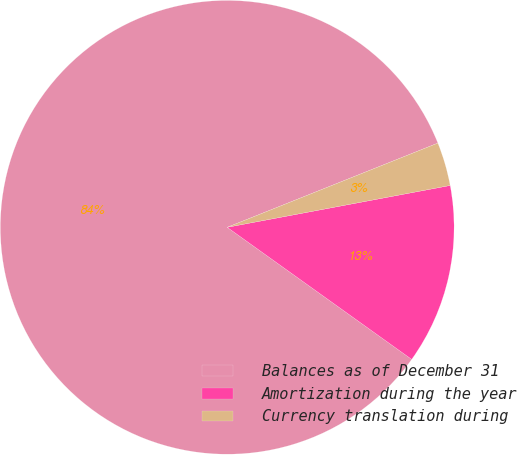Convert chart. <chart><loc_0><loc_0><loc_500><loc_500><pie_chart><fcel>Balances as of December 31<fcel>Amortization during the year<fcel>Currency translation during<nl><fcel>84.06%<fcel>12.84%<fcel>3.1%<nl></chart> 